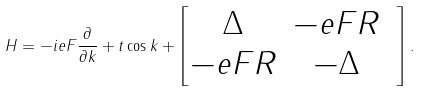Convert formula to latex. <formula><loc_0><loc_0><loc_500><loc_500>H = - i e F \frac { \partial } { \partial k } + t \cos k + \begin{bmatrix} \Delta & - e F R \\ - e F R & - \Delta & \end{bmatrix} .</formula> 